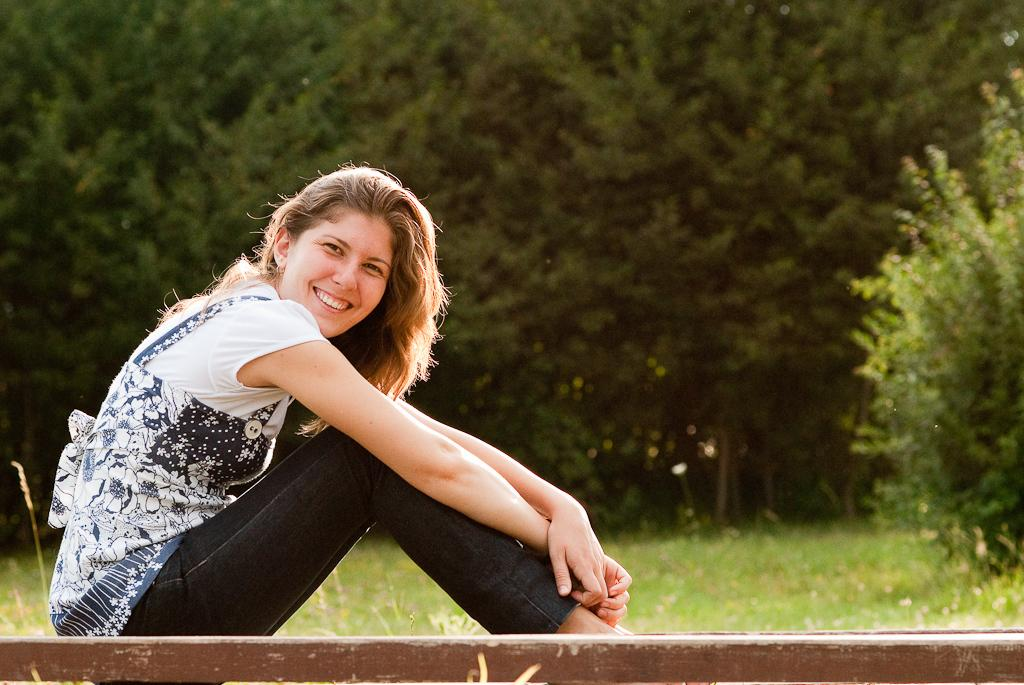What is the woman in the image doing? The woman is sitting and smiling in the image. What type of clothing is the woman wearing? The woman is wearing a top and trousers. Where is the image set? The image appears to be set in a wooded area. What type of ground cover can be seen in the image? There is grass visible in the image. What type of vegetation is present in the image? There are trees with branches and leaves in the image. What type of ball is the woman playing with in the image? There is no ball present in the image; the woman is sitting and smiling. What type of cannon is visible in the image? There is no cannon present in the image; the image is set in a wooded area with trees and grass. 